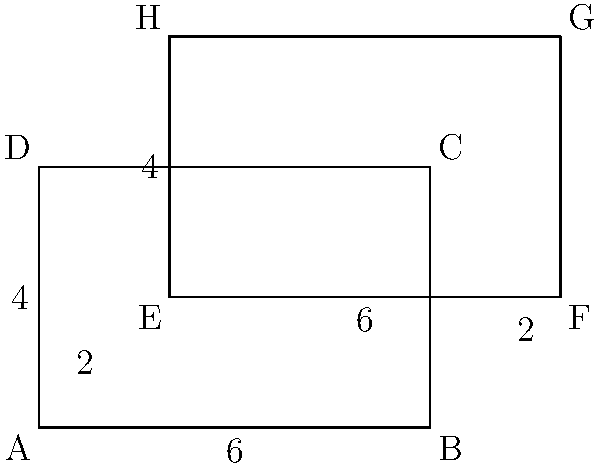Given two overlapping rectangles ABCD and EFGH as shown in the figure, where the dimensions are in meters, calculate the perimeter of the complex shape formed by their union. Provide your answer using a list comprehension to demonstrate your Haskell expertise. To solve this problem, we'll follow these steps:

1) Identify the outer edges of the complex shape:
   - Left edge: AD (4m)
   - Bottom edge: AB (6m)
   - Right edge: FG (4m)
   - Top edge: HG (6m)

2) Identify the additional segments that contribute to the perimeter:
   - DE (2m)
   - EF (4m)
   - BC (2m)

3) Sum up all these segments to get the total perimeter:
   4 + 6 + 4 + 6 + 2 + 4 + 2 = 28m

4) Express this as a Haskell list comprehension:
   
   Let's define a list of all segment lengths:
   segments = [4, 6, 4, 6, 2, 4, 2]

   Then, we can use a list comprehension to sum these:
   perimeter = sum [x | x <- segments]

This list comprehension takes each element x from the segments list and sums them up, giving us the total perimeter of 28m.
Answer: $$\text{perimeter} = \text{sum } [x \mid x \leftarrow [4, 6, 4, 6, 2, 4, 2]] = 28\text{m}$$ 